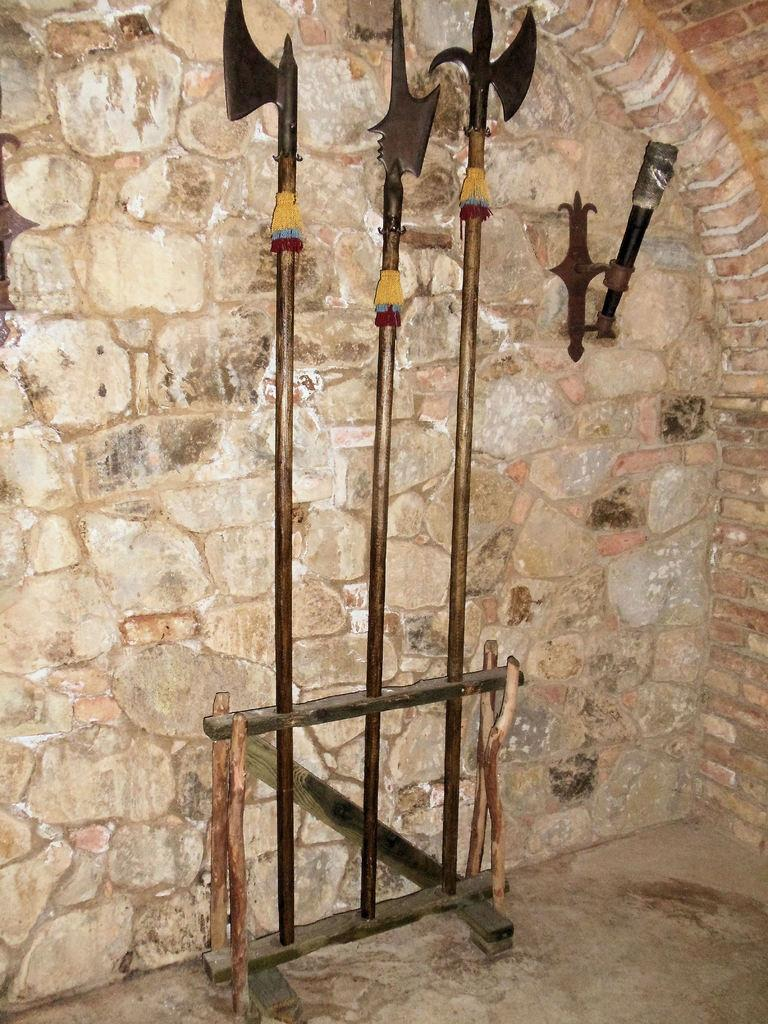What can be seen in the image related to combat or defense? There are different types of weapons in the image. Where are the weapons placed in the image? The weapons are kept in front of a wall. How many weapons are visible in the image? There are three weapons in total. What else can be seen on the wall in the image? There is an object attached to the wall. How many ladybugs are crawling on the weapons in the image? There are no ladybugs present in the image; it features different types of weapons in front of a wall. 